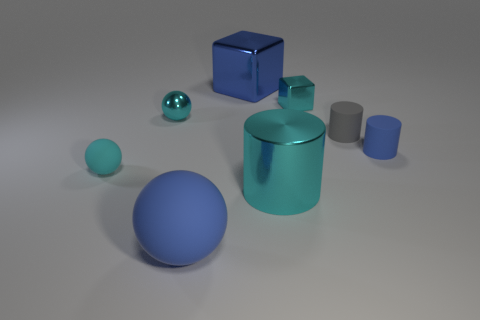Subtract 1 spheres. How many spheres are left? 2 Add 2 cyan things. How many objects exist? 10 Subtract all rubber spheres. How many spheres are left? 1 Add 2 big things. How many big things exist? 5 Subtract all gray cylinders. How many cylinders are left? 2 Subtract 0 purple spheres. How many objects are left? 8 Subtract all spheres. How many objects are left? 5 Subtract all cyan cubes. Subtract all green cylinders. How many cubes are left? 1 Subtract all red blocks. How many red cylinders are left? 0 Subtract all large shiny cubes. Subtract all large shiny cubes. How many objects are left? 6 